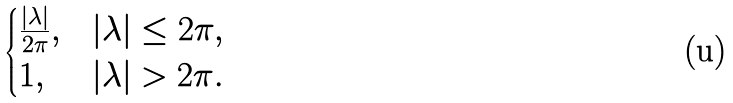<formula> <loc_0><loc_0><loc_500><loc_500>\begin{cases} \frac { | \lambda | } { 2 \pi } , & | \lambda | \leq 2 \pi , \\ 1 , & | \lambda | > 2 \pi . \end{cases}</formula> 